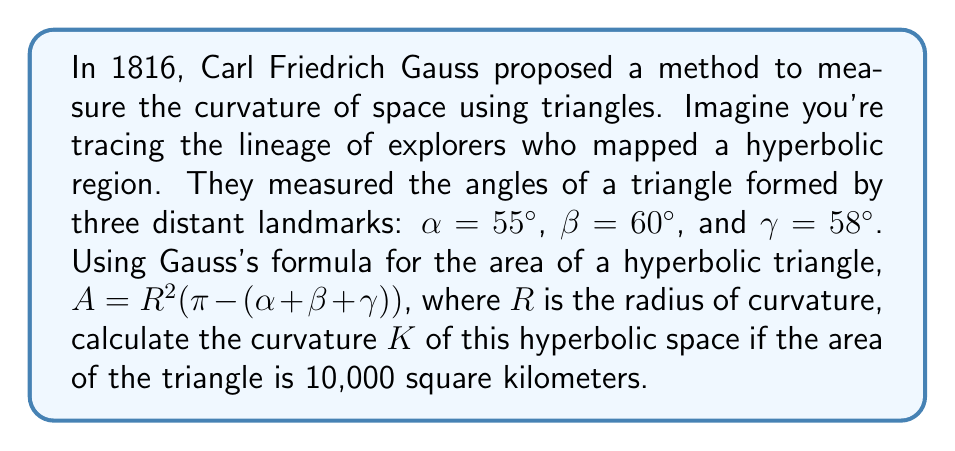Can you solve this math problem? To solve this problem, we'll follow these steps:

1) First, let's convert the given angles from degrees to radians:
   $\alpha = 55° \times \frac{\pi}{180°} = \frac{11\pi}{36}$ radians
   $\beta = 60° \times \frac{\pi}{180°} = \frac{\pi}{3}$ radians
   $\gamma = 58° \times \frac{\pi}{180°} = \frac{29\pi}{90}$ radians

2) Now, we can use Gauss's formula: $A = R^2(\pi - (\alpha + \beta + \gamma))$
   Substituting our values:
   $10,000 = R^2(\pi - (\frac{11\pi}{36} + \frac{\pi}{3} + \frac{29\pi}{90}))$

3) Simplify the right side of the equation:
   $10,000 = R^2(\pi - \frac{173\pi}{180})$
   $10,000 = R^2(\frac{7\pi}{180})$

4) Solve for $R$:
   $R^2 = \frac{10,000}{\frac{7\pi}{180}}$
   $R^2 = \frac{1,800,000}{7\pi}$
   $R = \sqrt{\frac{1,800,000}{7\pi}}$

5) The curvature $K$ is defined as $K = -\frac{1}{R^2}$ for a hyperbolic space.
   Therefore:
   $K = -\frac{1}{R^2} = -\frac{7\pi}{1,800,000} \approx -1.22 \times 10^{-5}$ km^(-2)
Answer: $K \approx -1.22 \times 10^{-5}$ km^(-2) 